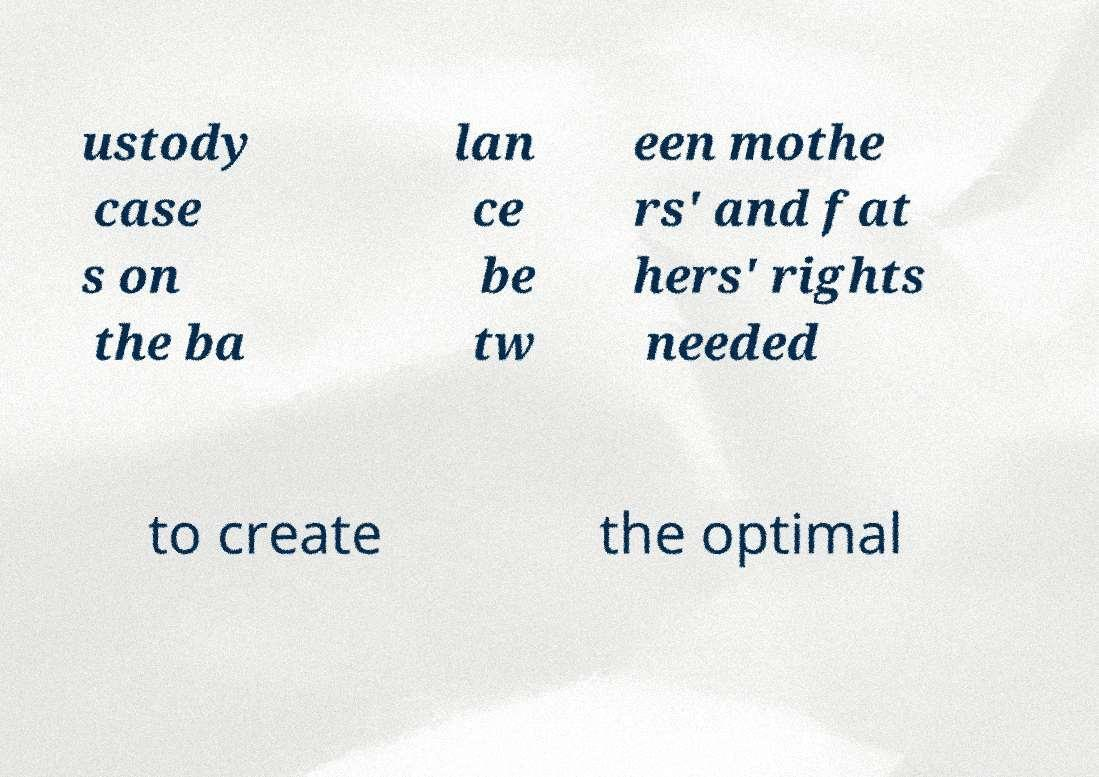There's text embedded in this image that I need extracted. Can you transcribe it verbatim? ustody case s on the ba lan ce be tw een mothe rs' and fat hers' rights needed to create the optimal 